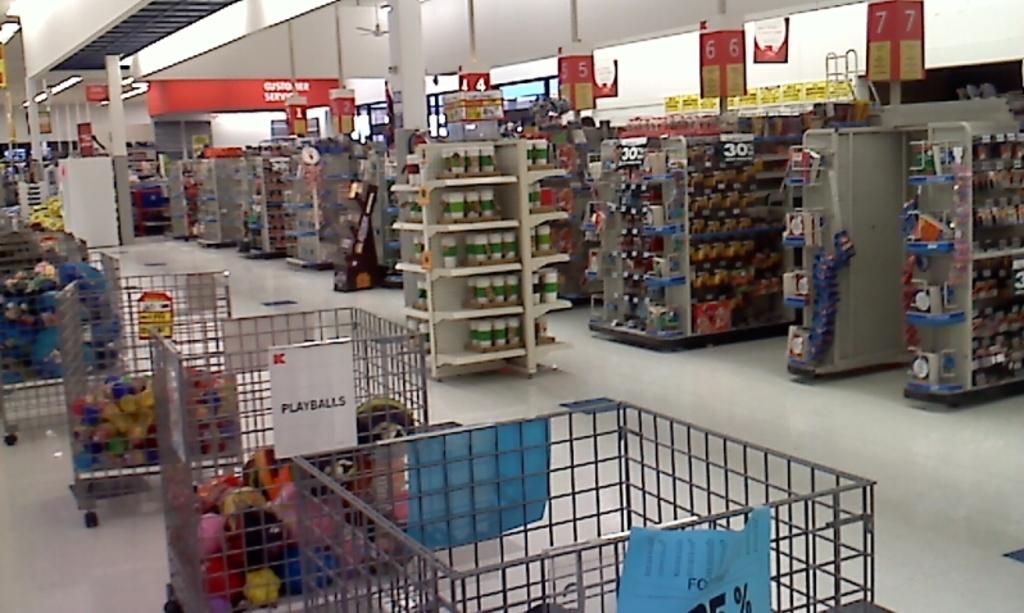<image>
Relay a brief, clear account of the picture shown. A bin in a store is full of play balls. 